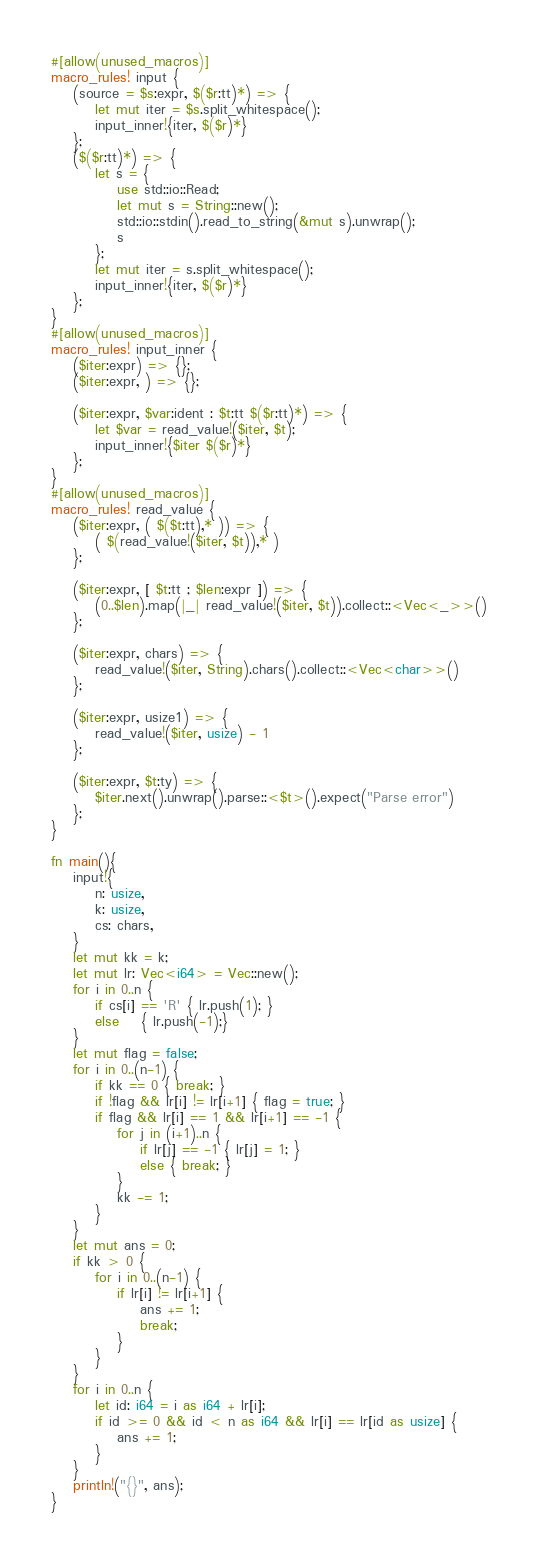Convert code to text. <code><loc_0><loc_0><loc_500><loc_500><_Rust_>#[allow(unused_macros)]
macro_rules! input {
    (source = $s:expr, $($r:tt)*) => {
        let mut iter = $s.split_whitespace();
        input_inner!{iter, $($r)*}
    };
    ($($r:tt)*) => {
        let s = {
            use std::io::Read;
            let mut s = String::new();
            std::io::stdin().read_to_string(&mut s).unwrap();
            s
        };
        let mut iter = s.split_whitespace();
        input_inner!{iter, $($r)*}
    };
}
#[allow(unused_macros)]
macro_rules! input_inner {
    ($iter:expr) => {};
    ($iter:expr, ) => {};

    ($iter:expr, $var:ident : $t:tt $($r:tt)*) => {
        let $var = read_value!($iter, $t);
        input_inner!{$iter $($r)*}
    };
}
#[allow(unused_macros)]
macro_rules! read_value {
    ($iter:expr, ( $($t:tt),* )) => {
        ( $(read_value!($iter, $t)),* )
    };

    ($iter:expr, [ $t:tt ; $len:expr ]) => {
        (0..$len).map(|_| read_value!($iter, $t)).collect::<Vec<_>>()
    };

    ($iter:expr, chars) => {
        read_value!($iter, String).chars().collect::<Vec<char>>()
    };

    ($iter:expr, usize1) => {
        read_value!($iter, usize) - 1
    };

    ($iter:expr, $t:ty) => {
        $iter.next().unwrap().parse::<$t>().expect("Parse error")
    };
}

fn main(){
	input!{
		n: usize,
		k: usize,
		cs: chars,
	}
	let mut kk = k;
	let mut lr: Vec<i64> = Vec::new();
	for i in 0..n {
		if cs[i] == 'R' { lr.push(1); }
		else 	{ lr.push(-1);}
	}
	let mut flag = false;
	for i in 0..(n-1) {
		if kk == 0 { break; }
		if !flag && lr[i] != lr[i+1] { flag = true; }
		if flag && lr[i] == 1 && lr[i+1] == -1 {
			for j in (i+1)..n {
				if lr[j] == -1 { lr[j] = 1; }
				else { break; }
			}
			kk -= 1;
		}
	}
	let mut ans = 0;
	if kk > 0 {
		for i in 0..(n-1) {
			if lr[i] != lr[i+1] {
				ans += 1;
				break;
			}
		}
	}
	for i in 0..n {
		let id: i64 = i as i64 + lr[i];
		if id >= 0 && id < n as i64 && lr[i] == lr[id as usize] {
			ans += 1;
		}
	}
	println!("{}", ans);
}</code> 